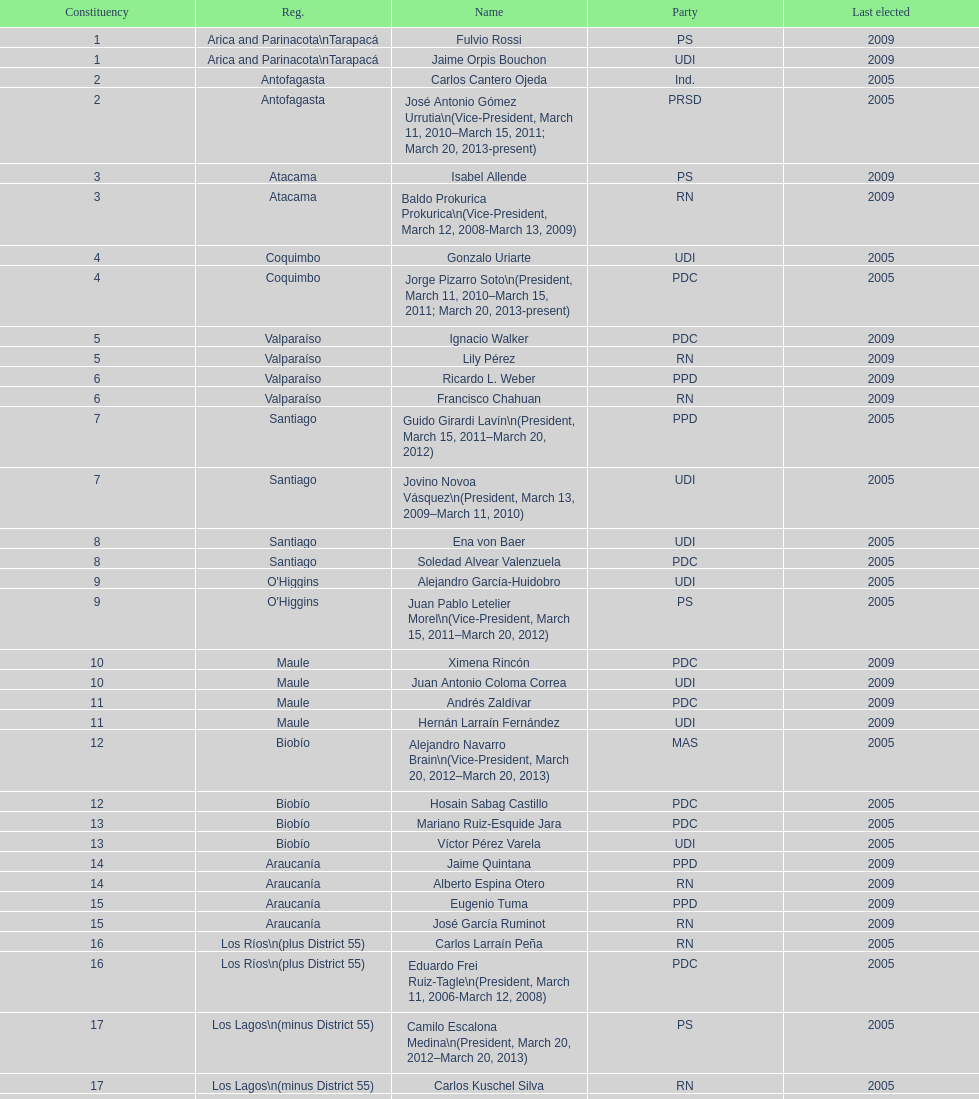What is the difference in years between constiuency 1 and 2? 4 years. 